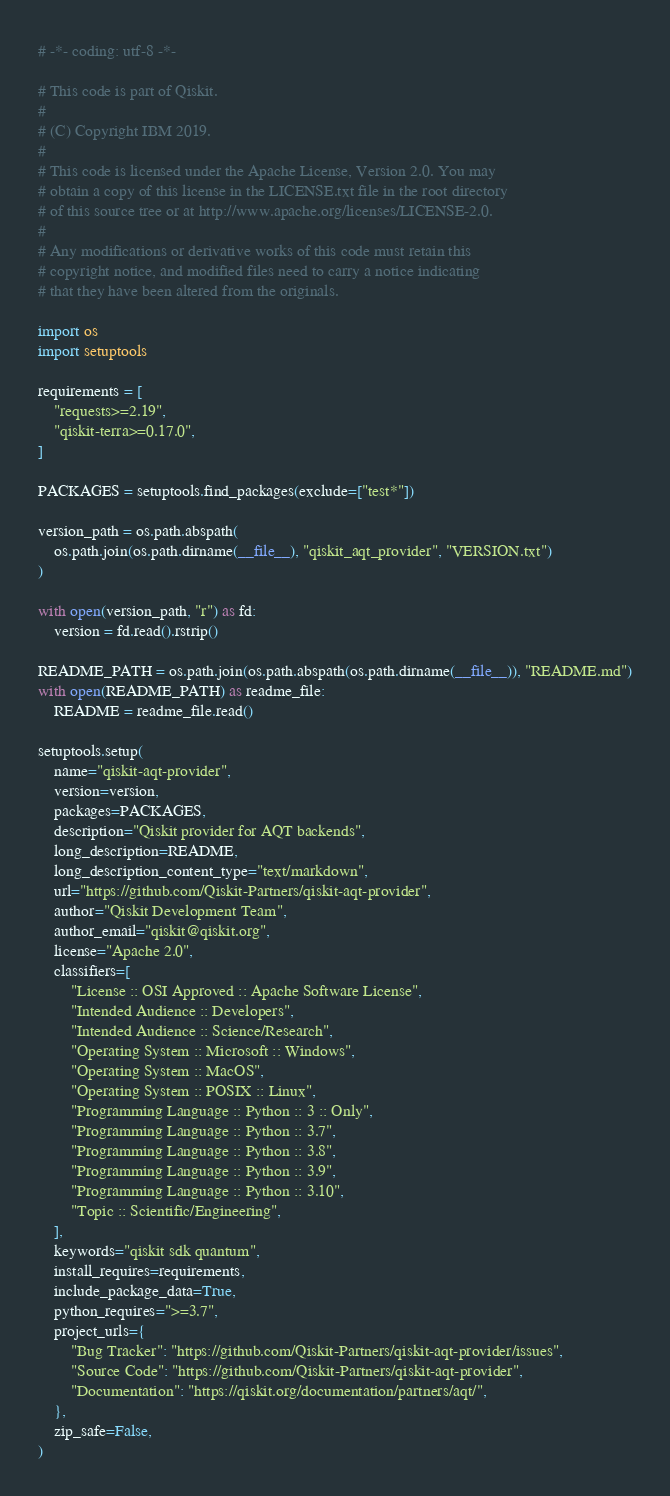<code> <loc_0><loc_0><loc_500><loc_500><_Python_># -*- coding: utf-8 -*-

# This code is part of Qiskit.
#
# (C) Copyright IBM 2019.
#
# This code is licensed under the Apache License, Version 2.0. You may
# obtain a copy of this license in the LICENSE.txt file in the root directory
# of this source tree or at http://www.apache.org/licenses/LICENSE-2.0.
#
# Any modifications or derivative works of this code must retain this
# copyright notice, and modified files need to carry a notice indicating
# that they have been altered from the originals.

import os
import setuptools

requirements = [
    "requests>=2.19",
    "qiskit-terra>=0.17.0",
]

PACKAGES = setuptools.find_packages(exclude=["test*"])

version_path = os.path.abspath(
    os.path.join(os.path.dirname(__file__), "qiskit_aqt_provider", "VERSION.txt")
)

with open(version_path, "r") as fd:
    version = fd.read().rstrip()

README_PATH = os.path.join(os.path.abspath(os.path.dirname(__file__)), "README.md")
with open(README_PATH) as readme_file:
    README = readme_file.read()

setuptools.setup(
    name="qiskit-aqt-provider",
    version=version,
    packages=PACKAGES,
    description="Qiskit provider for AQT backends",
    long_description=README,
    long_description_content_type="text/markdown",
    url="https://github.com/Qiskit-Partners/qiskit-aqt-provider",
    author="Qiskit Development Team",
    author_email="qiskit@qiskit.org",
    license="Apache 2.0",
    classifiers=[
        "License :: OSI Approved :: Apache Software License",
        "Intended Audience :: Developers",
        "Intended Audience :: Science/Research",
        "Operating System :: Microsoft :: Windows",
        "Operating System :: MacOS",
        "Operating System :: POSIX :: Linux",
        "Programming Language :: Python :: 3 :: Only",
        "Programming Language :: Python :: 3.7",
        "Programming Language :: Python :: 3.8",
        "Programming Language :: Python :: 3.9",
        "Programming Language :: Python :: 3.10",
        "Topic :: Scientific/Engineering",
    ],
    keywords="qiskit sdk quantum",
    install_requires=requirements,
    include_package_data=True,
    python_requires=">=3.7",
    project_urls={
        "Bug Tracker": "https://github.com/Qiskit-Partners/qiskit-aqt-provider/issues",
        "Source Code": "https://github.com/Qiskit-Partners/qiskit-aqt-provider",
        "Documentation": "https://qiskit.org/documentation/partners/aqt/",
    },
    zip_safe=False,
)
</code> 